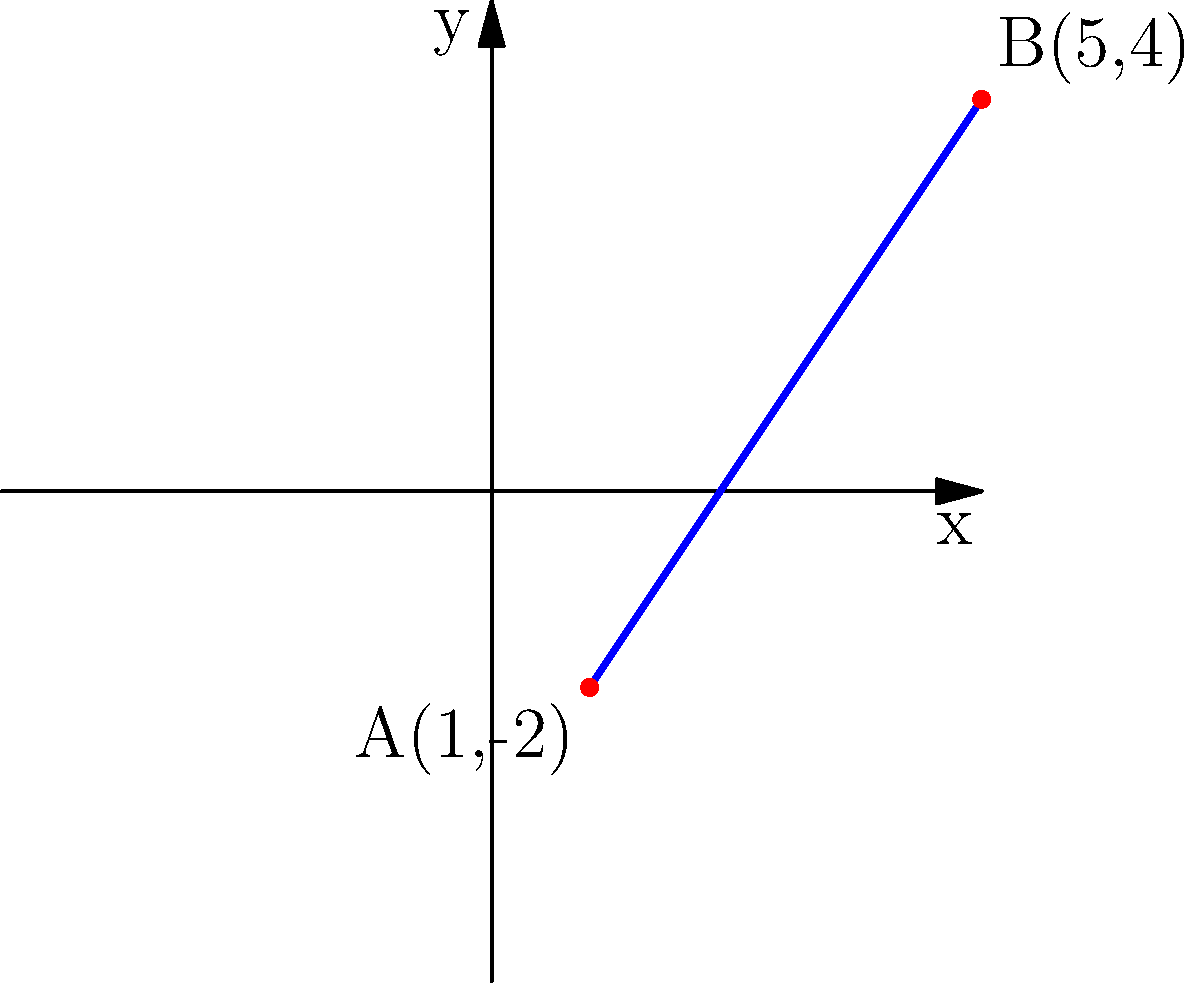Look at the blue line on the grid. It starts at point A(1,-2) and ends at point B(5,4). Can you find the middle point of this line? Let's find the middle point step by step:

1. To find the middle point, we need to calculate the average of the x-coordinates and y-coordinates of points A and B.

2. For the x-coordinate:
   * A's x is 1
   * B's x is 5
   * Middle x = $\frac{1 + 5}{2} = \frac{6}{2} = 3$

3. For the y-coordinate:
   * A's y is -2
   * B's y is 4
   * Middle y = $\frac{-2 + 4}{2} = \frac{2}{2} = 1$

4. So, the middle point is at (3,1).

5. You can check this by counting: it's 2 squares right and 3 squares up from A, and 2 squares left and 3 squares down from B.
Answer: (3,1) 